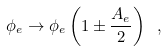<formula> <loc_0><loc_0><loc_500><loc_500>\phi _ { e } \to \phi _ { e } \left ( 1 \pm \frac { A _ { e } } { 2 } \right ) \ ,</formula> 